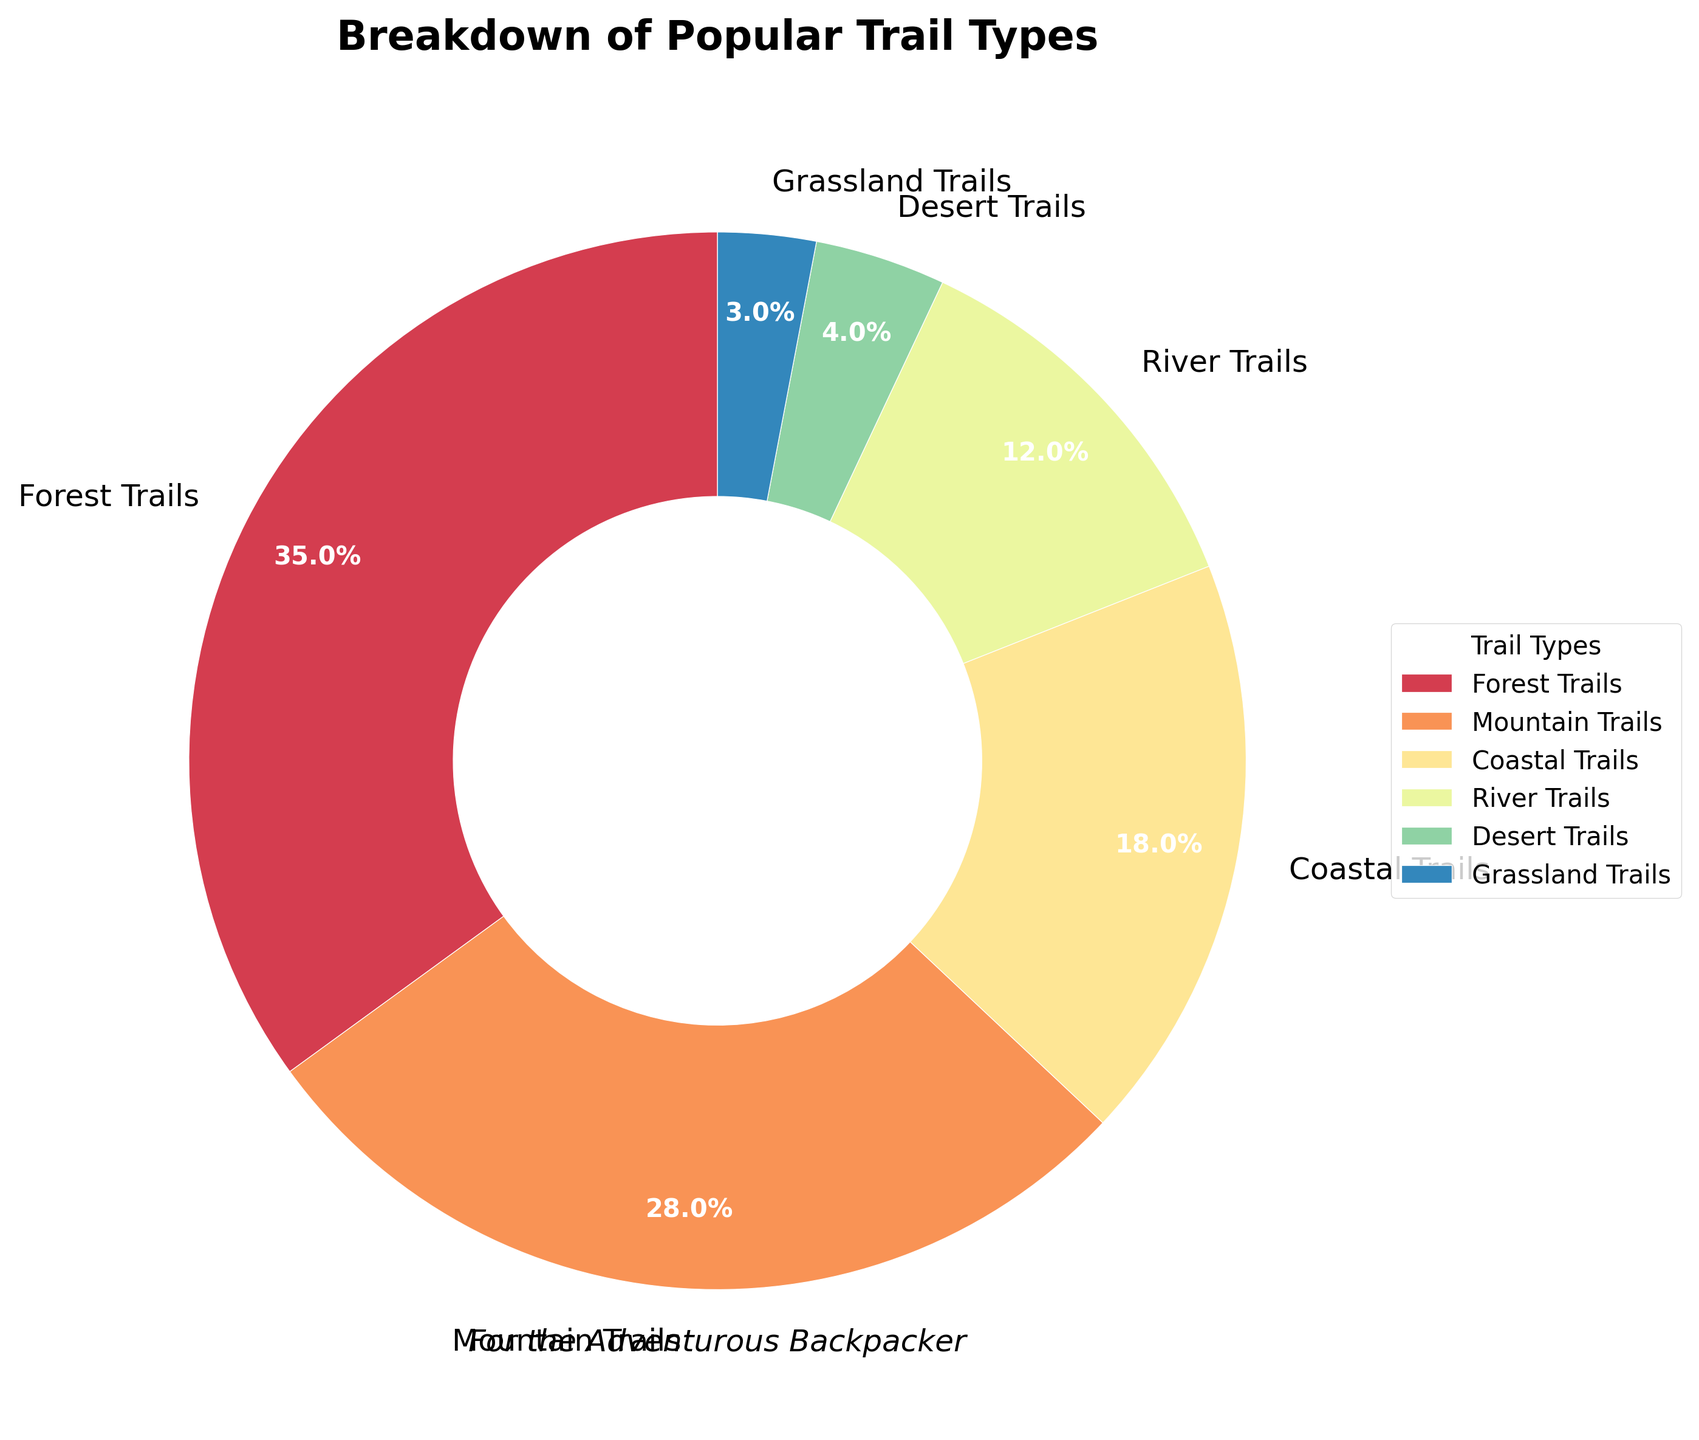What percentage of the trails are Forest Trails and Mountain Trails combined? Sum the percentages of Forest Trails and Mountain Trails: 35% + 28%. Combined, this accounts for 63%.
Answer: 63% Which trail type has the smallest percentage? Look at the different trail types and identify the one with the lowest percentage. The Grassland Trails contribute only 3%.
Answer: Grassland Trails Are there more Coastal Trails than River Trails? Compare the percentages of Coastal Trails (18%) and River Trails (12%). Coastal Trails have a higher percentage.
Answer: Yes What is the difference in percentage between Forest Trails and Desert Trails? Subtract the percentage of Desert Trails from Forest Trails: 35% - 4% = 31%.
Answer: 31% Which trail type accounts for more than a quarter of the trails? Identify the trail types with percentages over 25%. Forest Trails (35%) and Mountain Trails (28%) both exceed 25%.
Answer: Forest Trails and Mountain Trails How many trail types have percentages that are less than 10%? Count the trail types with percentages less than 10%. River Trails (12%), Desert Trails (4%), and Grassland Trails (3%) are the only ones below 10%.
Answer: 2 What is the average percentage of Coastal Trails, River Trails, and Desert Trails combined? Average percentage = (Coastal Trails 18% + River Trails 12% + Desert Trails 4%) / 3 = 34% / 3. The result is approximately 11.33%.
Answer: 11.33% How much larger is the percentage of Mountain Trails than Grassland Trails? Subtract the percentage of Grassland Trails from Mountain Trails: 28% - 3% = 25%.
Answer: 25% Which trail type is represented by the green color in the pie chart? The pie chart uses colors from a specific palette. Based on the provided code, the first color may represent Forest Trails; however, specific color assignment was not given, requiring visual examination.
Answer: (Visual examination needed) Does any single trail type make up almost half of the pie chart? Assess if any single trail type accounts for nearly 50% by examining percentages. The highest percentage is 35% for Forest Trails, which is not close to 50%.
Answer: No 